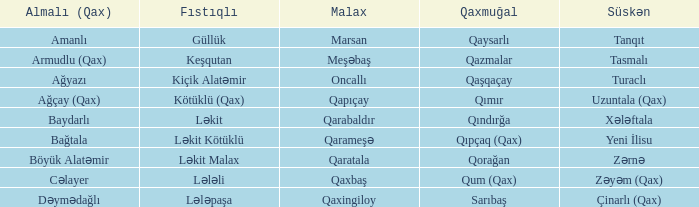What is the süskən village with a malax village forest leader? Tasmalı. 